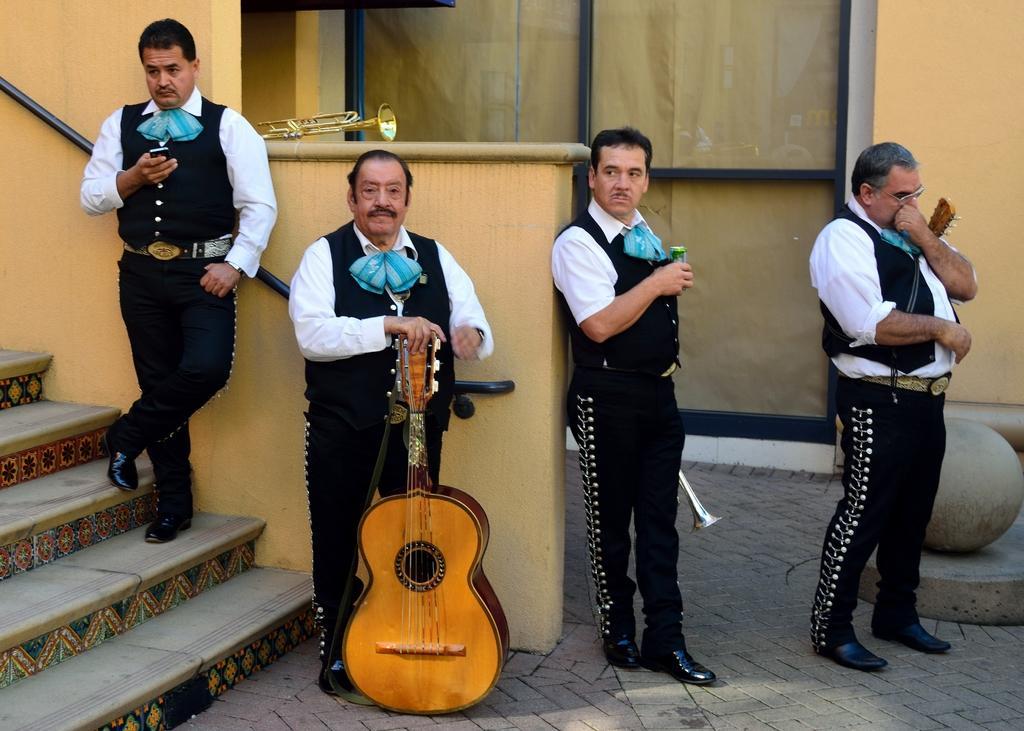Could you give a brief overview of what you see in this image? Here we can see a group of people standing on the floor, and holding a guitar and musical instruments in their hands, and here is the staircase, and at back here is the wall. 